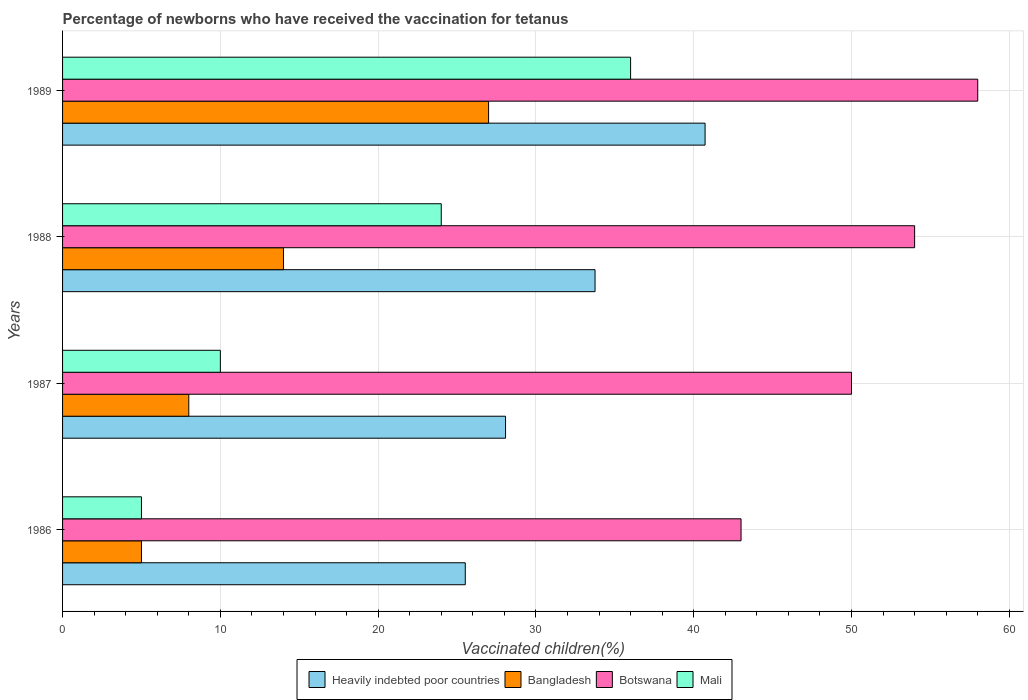How many groups of bars are there?
Ensure brevity in your answer.  4. Are the number of bars on each tick of the Y-axis equal?
Keep it short and to the point. Yes. How many bars are there on the 4th tick from the top?
Give a very brief answer. 4. How many bars are there on the 4th tick from the bottom?
Make the answer very short. 4. What is the percentage of vaccinated children in Bangladesh in 1986?
Give a very brief answer. 5. Across all years, what is the maximum percentage of vaccinated children in Heavily indebted poor countries?
Keep it short and to the point. 40.72. Across all years, what is the minimum percentage of vaccinated children in Bangladesh?
Offer a terse response. 5. In which year was the percentage of vaccinated children in Mali maximum?
Offer a very short reply. 1989. In which year was the percentage of vaccinated children in Heavily indebted poor countries minimum?
Provide a short and direct response. 1986. What is the total percentage of vaccinated children in Heavily indebted poor countries in the graph?
Provide a succinct answer. 128.06. What is the difference between the percentage of vaccinated children in Bangladesh in 1986 and that in 1987?
Keep it short and to the point. -3. What is the average percentage of vaccinated children in Botswana per year?
Your answer should be compact. 51.25. In the year 1987, what is the difference between the percentage of vaccinated children in Heavily indebted poor countries and percentage of vaccinated children in Mali?
Provide a succinct answer. 18.07. In how many years, is the percentage of vaccinated children in Heavily indebted poor countries greater than 36 %?
Give a very brief answer. 1. What is the ratio of the percentage of vaccinated children in Heavily indebted poor countries in 1987 to that in 1988?
Your answer should be compact. 0.83. Is the percentage of vaccinated children in Mali in 1988 less than that in 1989?
Ensure brevity in your answer.  Yes. What is the difference between the highest and the second highest percentage of vaccinated children in Bangladesh?
Keep it short and to the point. 13. What is the difference between the highest and the lowest percentage of vaccinated children in Mali?
Your answer should be very brief. 31. Is it the case that in every year, the sum of the percentage of vaccinated children in Mali and percentage of vaccinated children in Heavily indebted poor countries is greater than the sum of percentage of vaccinated children in Botswana and percentage of vaccinated children in Bangladesh?
Keep it short and to the point. No. What does the 1st bar from the top in 1989 represents?
Your answer should be very brief. Mali. Is it the case that in every year, the sum of the percentage of vaccinated children in Botswana and percentage of vaccinated children in Mali is greater than the percentage of vaccinated children in Bangladesh?
Provide a succinct answer. Yes. How many bars are there?
Your response must be concise. 16. Are all the bars in the graph horizontal?
Give a very brief answer. Yes. How many years are there in the graph?
Make the answer very short. 4. Are the values on the major ticks of X-axis written in scientific E-notation?
Your response must be concise. No. Does the graph contain any zero values?
Give a very brief answer. No. Does the graph contain grids?
Your response must be concise. Yes. Where does the legend appear in the graph?
Make the answer very short. Bottom center. How many legend labels are there?
Offer a terse response. 4. What is the title of the graph?
Offer a terse response. Percentage of newborns who have received the vaccination for tetanus. What is the label or title of the X-axis?
Offer a terse response. Vaccinated children(%). What is the Vaccinated children(%) of Heavily indebted poor countries in 1986?
Provide a short and direct response. 25.52. What is the Vaccinated children(%) of Heavily indebted poor countries in 1987?
Ensure brevity in your answer.  28.07. What is the Vaccinated children(%) in Heavily indebted poor countries in 1988?
Your answer should be compact. 33.75. What is the Vaccinated children(%) of Bangladesh in 1988?
Give a very brief answer. 14. What is the Vaccinated children(%) of Botswana in 1988?
Provide a succinct answer. 54. What is the Vaccinated children(%) in Mali in 1988?
Ensure brevity in your answer.  24. What is the Vaccinated children(%) in Heavily indebted poor countries in 1989?
Offer a terse response. 40.72. Across all years, what is the maximum Vaccinated children(%) of Heavily indebted poor countries?
Keep it short and to the point. 40.72. Across all years, what is the maximum Vaccinated children(%) of Botswana?
Your answer should be very brief. 58. Across all years, what is the maximum Vaccinated children(%) of Mali?
Your answer should be compact. 36. Across all years, what is the minimum Vaccinated children(%) in Heavily indebted poor countries?
Provide a succinct answer. 25.52. What is the total Vaccinated children(%) in Heavily indebted poor countries in the graph?
Keep it short and to the point. 128.06. What is the total Vaccinated children(%) in Botswana in the graph?
Your response must be concise. 205. What is the total Vaccinated children(%) of Mali in the graph?
Provide a short and direct response. 75. What is the difference between the Vaccinated children(%) in Heavily indebted poor countries in 1986 and that in 1987?
Your answer should be very brief. -2.55. What is the difference between the Vaccinated children(%) in Heavily indebted poor countries in 1986 and that in 1988?
Your answer should be very brief. -8.22. What is the difference between the Vaccinated children(%) of Bangladesh in 1986 and that in 1988?
Offer a very short reply. -9. What is the difference between the Vaccinated children(%) in Botswana in 1986 and that in 1988?
Your answer should be very brief. -11. What is the difference between the Vaccinated children(%) in Mali in 1986 and that in 1988?
Keep it short and to the point. -19. What is the difference between the Vaccinated children(%) of Heavily indebted poor countries in 1986 and that in 1989?
Give a very brief answer. -15.2. What is the difference between the Vaccinated children(%) of Botswana in 1986 and that in 1989?
Provide a short and direct response. -15. What is the difference between the Vaccinated children(%) in Mali in 1986 and that in 1989?
Your response must be concise. -31. What is the difference between the Vaccinated children(%) of Heavily indebted poor countries in 1987 and that in 1988?
Ensure brevity in your answer.  -5.67. What is the difference between the Vaccinated children(%) in Bangladesh in 1987 and that in 1988?
Offer a very short reply. -6. What is the difference between the Vaccinated children(%) of Botswana in 1987 and that in 1988?
Give a very brief answer. -4. What is the difference between the Vaccinated children(%) in Heavily indebted poor countries in 1987 and that in 1989?
Give a very brief answer. -12.65. What is the difference between the Vaccinated children(%) in Botswana in 1987 and that in 1989?
Provide a short and direct response. -8. What is the difference between the Vaccinated children(%) of Heavily indebted poor countries in 1988 and that in 1989?
Your answer should be compact. -6.97. What is the difference between the Vaccinated children(%) in Mali in 1988 and that in 1989?
Offer a very short reply. -12. What is the difference between the Vaccinated children(%) of Heavily indebted poor countries in 1986 and the Vaccinated children(%) of Bangladesh in 1987?
Offer a very short reply. 17.52. What is the difference between the Vaccinated children(%) in Heavily indebted poor countries in 1986 and the Vaccinated children(%) in Botswana in 1987?
Provide a succinct answer. -24.48. What is the difference between the Vaccinated children(%) of Heavily indebted poor countries in 1986 and the Vaccinated children(%) of Mali in 1987?
Ensure brevity in your answer.  15.52. What is the difference between the Vaccinated children(%) in Bangladesh in 1986 and the Vaccinated children(%) in Botswana in 1987?
Ensure brevity in your answer.  -45. What is the difference between the Vaccinated children(%) in Bangladesh in 1986 and the Vaccinated children(%) in Mali in 1987?
Your answer should be compact. -5. What is the difference between the Vaccinated children(%) in Heavily indebted poor countries in 1986 and the Vaccinated children(%) in Bangladesh in 1988?
Provide a short and direct response. 11.52. What is the difference between the Vaccinated children(%) of Heavily indebted poor countries in 1986 and the Vaccinated children(%) of Botswana in 1988?
Your answer should be compact. -28.48. What is the difference between the Vaccinated children(%) in Heavily indebted poor countries in 1986 and the Vaccinated children(%) in Mali in 1988?
Keep it short and to the point. 1.52. What is the difference between the Vaccinated children(%) of Bangladesh in 1986 and the Vaccinated children(%) of Botswana in 1988?
Give a very brief answer. -49. What is the difference between the Vaccinated children(%) of Heavily indebted poor countries in 1986 and the Vaccinated children(%) of Bangladesh in 1989?
Give a very brief answer. -1.48. What is the difference between the Vaccinated children(%) in Heavily indebted poor countries in 1986 and the Vaccinated children(%) in Botswana in 1989?
Offer a terse response. -32.48. What is the difference between the Vaccinated children(%) of Heavily indebted poor countries in 1986 and the Vaccinated children(%) of Mali in 1989?
Provide a short and direct response. -10.48. What is the difference between the Vaccinated children(%) of Bangladesh in 1986 and the Vaccinated children(%) of Botswana in 1989?
Make the answer very short. -53. What is the difference between the Vaccinated children(%) in Bangladesh in 1986 and the Vaccinated children(%) in Mali in 1989?
Provide a short and direct response. -31. What is the difference between the Vaccinated children(%) of Botswana in 1986 and the Vaccinated children(%) of Mali in 1989?
Ensure brevity in your answer.  7. What is the difference between the Vaccinated children(%) of Heavily indebted poor countries in 1987 and the Vaccinated children(%) of Bangladesh in 1988?
Provide a short and direct response. 14.07. What is the difference between the Vaccinated children(%) in Heavily indebted poor countries in 1987 and the Vaccinated children(%) in Botswana in 1988?
Provide a succinct answer. -25.93. What is the difference between the Vaccinated children(%) of Heavily indebted poor countries in 1987 and the Vaccinated children(%) of Mali in 1988?
Give a very brief answer. 4.07. What is the difference between the Vaccinated children(%) of Bangladesh in 1987 and the Vaccinated children(%) of Botswana in 1988?
Offer a very short reply. -46. What is the difference between the Vaccinated children(%) in Bangladesh in 1987 and the Vaccinated children(%) in Mali in 1988?
Ensure brevity in your answer.  -16. What is the difference between the Vaccinated children(%) in Heavily indebted poor countries in 1987 and the Vaccinated children(%) in Bangladesh in 1989?
Your answer should be very brief. 1.07. What is the difference between the Vaccinated children(%) of Heavily indebted poor countries in 1987 and the Vaccinated children(%) of Botswana in 1989?
Provide a short and direct response. -29.93. What is the difference between the Vaccinated children(%) in Heavily indebted poor countries in 1987 and the Vaccinated children(%) in Mali in 1989?
Your answer should be very brief. -7.93. What is the difference between the Vaccinated children(%) of Heavily indebted poor countries in 1988 and the Vaccinated children(%) of Bangladesh in 1989?
Offer a very short reply. 6.75. What is the difference between the Vaccinated children(%) in Heavily indebted poor countries in 1988 and the Vaccinated children(%) in Botswana in 1989?
Ensure brevity in your answer.  -24.25. What is the difference between the Vaccinated children(%) in Heavily indebted poor countries in 1988 and the Vaccinated children(%) in Mali in 1989?
Keep it short and to the point. -2.25. What is the difference between the Vaccinated children(%) in Bangladesh in 1988 and the Vaccinated children(%) in Botswana in 1989?
Keep it short and to the point. -44. What is the difference between the Vaccinated children(%) of Bangladesh in 1988 and the Vaccinated children(%) of Mali in 1989?
Offer a very short reply. -22. What is the difference between the Vaccinated children(%) in Botswana in 1988 and the Vaccinated children(%) in Mali in 1989?
Keep it short and to the point. 18. What is the average Vaccinated children(%) in Heavily indebted poor countries per year?
Give a very brief answer. 32.02. What is the average Vaccinated children(%) of Bangladesh per year?
Keep it short and to the point. 13.5. What is the average Vaccinated children(%) in Botswana per year?
Your answer should be very brief. 51.25. What is the average Vaccinated children(%) in Mali per year?
Offer a very short reply. 18.75. In the year 1986, what is the difference between the Vaccinated children(%) of Heavily indebted poor countries and Vaccinated children(%) of Bangladesh?
Your answer should be very brief. 20.52. In the year 1986, what is the difference between the Vaccinated children(%) in Heavily indebted poor countries and Vaccinated children(%) in Botswana?
Provide a succinct answer. -17.48. In the year 1986, what is the difference between the Vaccinated children(%) of Heavily indebted poor countries and Vaccinated children(%) of Mali?
Provide a succinct answer. 20.52. In the year 1986, what is the difference between the Vaccinated children(%) of Bangladesh and Vaccinated children(%) of Botswana?
Provide a short and direct response. -38. In the year 1987, what is the difference between the Vaccinated children(%) of Heavily indebted poor countries and Vaccinated children(%) of Bangladesh?
Your answer should be compact. 20.07. In the year 1987, what is the difference between the Vaccinated children(%) in Heavily indebted poor countries and Vaccinated children(%) in Botswana?
Make the answer very short. -21.93. In the year 1987, what is the difference between the Vaccinated children(%) of Heavily indebted poor countries and Vaccinated children(%) of Mali?
Keep it short and to the point. 18.07. In the year 1987, what is the difference between the Vaccinated children(%) in Bangladesh and Vaccinated children(%) in Botswana?
Your answer should be very brief. -42. In the year 1987, what is the difference between the Vaccinated children(%) of Botswana and Vaccinated children(%) of Mali?
Offer a very short reply. 40. In the year 1988, what is the difference between the Vaccinated children(%) in Heavily indebted poor countries and Vaccinated children(%) in Bangladesh?
Your answer should be very brief. 19.75. In the year 1988, what is the difference between the Vaccinated children(%) of Heavily indebted poor countries and Vaccinated children(%) of Botswana?
Your response must be concise. -20.25. In the year 1988, what is the difference between the Vaccinated children(%) in Heavily indebted poor countries and Vaccinated children(%) in Mali?
Offer a terse response. 9.75. In the year 1988, what is the difference between the Vaccinated children(%) of Bangladesh and Vaccinated children(%) of Mali?
Provide a succinct answer. -10. In the year 1989, what is the difference between the Vaccinated children(%) of Heavily indebted poor countries and Vaccinated children(%) of Bangladesh?
Keep it short and to the point. 13.72. In the year 1989, what is the difference between the Vaccinated children(%) in Heavily indebted poor countries and Vaccinated children(%) in Botswana?
Provide a succinct answer. -17.28. In the year 1989, what is the difference between the Vaccinated children(%) of Heavily indebted poor countries and Vaccinated children(%) of Mali?
Make the answer very short. 4.72. In the year 1989, what is the difference between the Vaccinated children(%) in Bangladesh and Vaccinated children(%) in Botswana?
Offer a very short reply. -31. In the year 1989, what is the difference between the Vaccinated children(%) of Bangladesh and Vaccinated children(%) of Mali?
Offer a terse response. -9. What is the ratio of the Vaccinated children(%) in Heavily indebted poor countries in 1986 to that in 1987?
Your response must be concise. 0.91. What is the ratio of the Vaccinated children(%) of Bangladesh in 1986 to that in 1987?
Offer a very short reply. 0.62. What is the ratio of the Vaccinated children(%) in Botswana in 1986 to that in 1987?
Your answer should be compact. 0.86. What is the ratio of the Vaccinated children(%) of Heavily indebted poor countries in 1986 to that in 1988?
Offer a very short reply. 0.76. What is the ratio of the Vaccinated children(%) in Bangladesh in 1986 to that in 1988?
Make the answer very short. 0.36. What is the ratio of the Vaccinated children(%) in Botswana in 1986 to that in 1988?
Provide a short and direct response. 0.8. What is the ratio of the Vaccinated children(%) of Mali in 1986 to that in 1988?
Keep it short and to the point. 0.21. What is the ratio of the Vaccinated children(%) in Heavily indebted poor countries in 1986 to that in 1989?
Your response must be concise. 0.63. What is the ratio of the Vaccinated children(%) of Bangladesh in 1986 to that in 1989?
Offer a very short reply. 0.19. What is the ratio of the Vaccinated children(%) of Botswana in 1986 to that in 1989?
Your response must be concise. 0.74. What is the ratio of the Vaccinated children(%) of Mali in 1986 to that in 1989?
Your response must be concise. 0.14. What is the ratio of the Vaccinated children(%) in Heavily indebted poor countries in 1987 to that in 1988?
Make the answer very short. 0.83. What is the ratio of the Vaccinated children(%) in Botswana in 1987 to that in 1988?
Offer a terse response. 0.93. What is the ratio of the Vaccinated children(%) of Mali in 1987 to that in 1988?
Provide a short and direct response. 0.42. What is the ratio of the Vaccinated children(%) in Heavily indebted poor countries in 1987 to that in 1989?
Your answer should be very brief. 0.69. What is the ratio of the Vaccinated children(%) of Bangladesh in 1987 to that in 1989?
Make the answer very short. 0.3. What is the ratio of the Vaccinated children(%) in Botswana in 1987 to that in 1989?
Offer a very short reply. 0.86. What is the ratio of the Vaccinated children(%) of Mali in 1987 to that in 1989?
Provide a short and direct response. 0.28. What is the ratio of the Vaccinated children(%) in Heavily indebted poor countries in 1988 to that in 1989?
Provide a succinct answer. 0.83. What is the ratio of the Vaccinated children(%) in Bangladesh in 1988 to that in 1989?
Offer a terse response. 0.52. What is the difference between the highest and the second highest Vaccinated children(%) in Heavily indebted poor countries?
Offer a terse response. 6.97. What is the difference between the highest and the second highest Vaccinated children(%) of Bangladesh?
Your answer should be compact. 13. What is the difference between the highest and the second highest Vaccinated children(%) of Mali?
Make the answer very short. 12. What is the difference between the highest and the lowest Vaccinated children(%) of Heavily indebted poor countries?
Give a very brief answer. 15.2. What is the difference between the highest and the lowest Vaccinated children(%) in Bangladesh?
Keep it short and to the point. 22. What is the difference between the highest and the lowest Vaccinated children(%) of Mali?
Offer a very short reply. 31. 